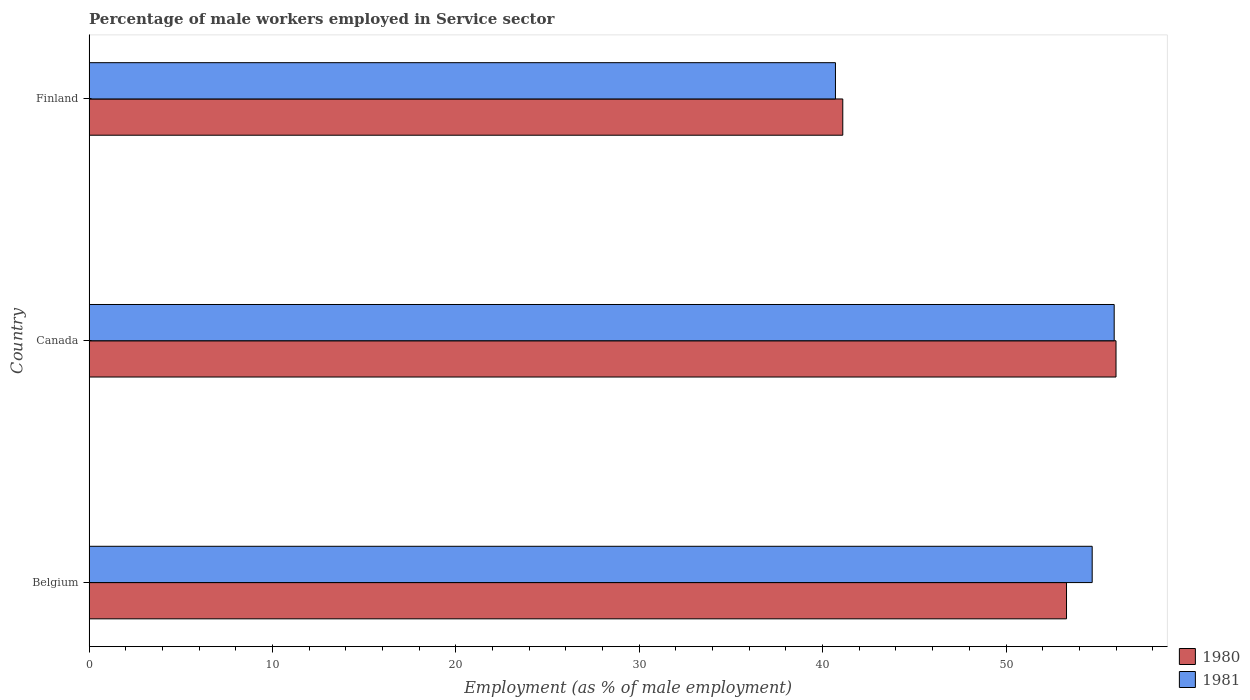Are the number of bars per tick equal to the number of legend labels?
Offer a very short reply. Yes. Are the number of bars on each tick of the Y-axis equal?
Your answer should be compact. Yes. How many bars are there on the 3rd tick from the top?
Your answer should be compact. 2. How many bars are there on the 2nd tick from the bottom?
Offer a very short reply. 2. What is the label of the 2nd group of bars from the top?
Your answer should be very brief. Canada. In how many cases, is the number of bars for a given country not equal to the number of legend labels?
Give a very brief answer. 0. What is the percentage of male workers employed in Service sector in 1981 in Finland?
Ensure brevity in your answer.  40.7. Across all countries, what is the maximum percentage of male workers employed in Service sector in 1981?
Make the answer very short. 55.9. Across all countries, what is the minimum percentage of male workers employed in Service sector in 1981?
Ensure brevity in your answer.  40.7. What is the total percentage of male workers employed in Service sector in 1981 in the graph?
Keep it short and to the point. 151.3. What is the difference between the percentage of male workers employed in Service sector in 1981 in Belgium and that in Canada?
Provide a short and direct response. -1.2. What is the difference between the percentage of male workers employed in Service sector in 1981 in Belgium and the percentage of male workers employed in Service sector in 1980 in Canada?
Offer a very short reply. -1.3. What is the average percentage of male workers employed in Service sector in 1980 per country?
Give a very brief answer. 50.13. What is the difference between the percentage of male workers employed in Service sector in 1981 and percentage of male workers employed in Service sector in 1980 in Finland?
Your answer should be compact. -0.4. What is the ratio of the percentage of male workers employed in Service sector in 1981 in Belgium to that in Canada?
Keep it short and to the point. 0.98. Is the difference between the percentage of male workers employed in Service sector in 1981 in Canada and Finland greater than the difference between the percentage of male workers employed in Service sector in 1980 in Canada and Finland?
Offer a terse response. Yes. What is the difference between the highest and the second highest percentage of male workers employed in Service sector in 1980?
Your answer should be very brief. 2.7. What is the difference between the highest and the lowest percentage of male workers employed in Service sector in 1980?
Ensure brevity in your answer.  14.9. What does the 1st bar from the top in Finland represents?
Your answer should be compact. 1981. What does the 2nd bar from the bottom in Canada represents?
Offer a very short reply. 1981. How many bars are there?
Your answer should be compact. 6. Are all the bars in the graph horizontal?
Your answer should be compact. Yes. What is the difference between two consecutive major ticks on the X-axis?
Make the answer very short. 10. Are the values on the major ticks of X-axis written in scientific E-notation?
Ensure brevity in your answer.  No. Does the graph contain any zero values?
Keep it short and to the point. No. Does the graph contain grids?
Keep it short and to the point. No. How are the legend labels stacked?
Ensure brevity in your answer.  Vertical. What is the title of the graph?
Provide a short and direct response. Percentage of male workers employed in Service sector. What is the label or title of the X-axis?
Provide a succinct answer. Employment (as % of male employment). What is the label or title of the Y-axis?
Provide a short and direct response. Country. What is the Employment (as % of male employment) of 1980 in Belgium?
Your answer should be very brief. 53.3. What is the Employment (as % of male employment) of 1981 in Belgium?
Your response must be concise. 54.7. What is the Employment (as % of male employment) of 1980 in Canada?
Provide a succinct answer. 56. What is the Employment (as % of male employment) in 1981 in Canada?
Offer a very short reply. 55.9. What is the Employment (as % of male employment) of 1980 in Finland?
Provide a short and direct response. 41.1. What is the Employment (as % of male employment) of 1981 in Finland?
Ensure brevity in your answer.  40.7. Across all countries, what is the maximum Employment (as % of male employment) in 1981?
Offer a terse response. 55.9. Across all countries, what is the minimum Employment (as % of male employment) in 1980?
Your answer should be compact. 41.1. Across all countries, what is the minimum Employment (as % of male employment) of 1981?
Your response must be concise. 40.7. What is the total Employment (as % of male employment) of 1980 in the graph?
Offer a very short reply. 150.4. What is the total Employment (as % of male employment) of 1981 in the graph?
Offer a terse response. 151.3. What is the difference between the Employment (as % of male employment) in 1980 in Belgium and that in Finland?
Provide a succinct answer. 12.2. What is the difference between the Employment (as % of male employment) of 1980 in Canada and that in Finland?
Offer a very short reply. 14.9. What is the difference between the Employment (as % of male employment) of 1980 in Belgium and the Employment (as % of male employment) of 1981 in Canada?
Make the answer very short. -2.6. What is the difference between the Employment (as % of male employment) in 1980 in Belgium and the Employment (as % of male employment) in 1981 in Finland?
Your response must be concise. 12.6. What is the difference between the Employment (as % of male employment) of 1980 in Canada and the Employment (as % of male employment) of 1981 in Finland?
Provide a short and direct response. 15.3. What is the average Employment (as % of male employment) of 1980 per country?
Your response must be concise. 50.13. What is the average Employment (as % of male employment) in 1981 per country?
Make the answer very short. 50.43. What is the difference between the Employment (as % of male employment) in 1980 and Employment (as % of male employment) in 1981 in Belgium?
Give a very brief answer. -1.4. What is the difference between the Employment (as % of male employment) of 1980 and Employment (as % of male employment) of 1981 in Canada?
Give a very brief answer. 0.1. What is the difference between the Employment (as % of male employment) of 1980 and Employment (as % of male employment) of 1981 in Finland?
Offer a terse response. 0.4. What is the ratio of the Employment (as % of male employment) in 1980 in Belgium to that in Canada?
Provide a short and direct response. 0.95. What is the ratio of the Employment (as % of male employment) in 1981 in Belgium to that in Canada?
Provide a short and direct response. 0.98. What is the ratio of the Employment (as % of male employment) in 1980 in Belgium to that in Finland?
Ensure brevity in your answer.  1.3. What is the ratio of the Employment (as % of male employment) of 1981 in Belgium to that in Finland?
Provide a short and direct response. 1.34. What is the ratio of the Employment (as % of male employment) of 1980 in Canada to that in Finland?
Provide a short and direct response. 1.36. What is the ratio of the Employment (as % of male employment) of 1981 in Canada to that in Finland?
Keep it short and to the point. 1.37. What is the difference between the highest and the second highest Employment (as % of male employment) in 1980?
Your answer should be compact. 2.7. What is the difference between the highest and the second highest Employment (as % of male employment) in 1981?
Offer a terse response. 1.2. 